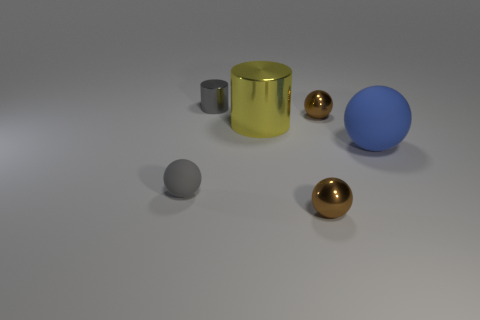Add 1 tiny rubber spheres. How many objects exist? 7 Subtract all blue balls. How many balls are left? 3 Subtract all small balls. How many balls are left? 1 Subtract 1 blue spheres. How many objects are left? 5 Subtract all cylinders. How many objects are left? 4 Subtract 2 balls. How many balls are left? 2 Subtract all red spheres. Subtract all cyan blocks. How many spheres are left? 4 Subtract all green cylinders. How many cyan balls are left? 0 Subtract all tiny brown metal things. Subtract all tiny metal objects. How many objects are left? 1 Add 5 tiny gray shiny cylinders. How many tiny gray shiny cylinders are left? 6 